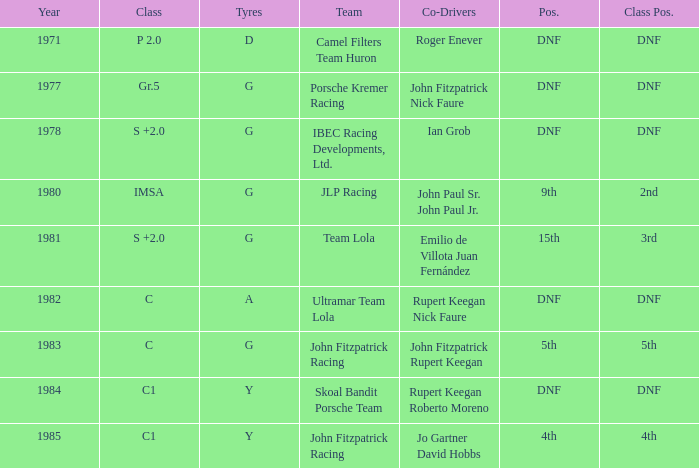Who was the co-driver that had a class position of 2nd? John Paul Sr. John Paul Jr. 